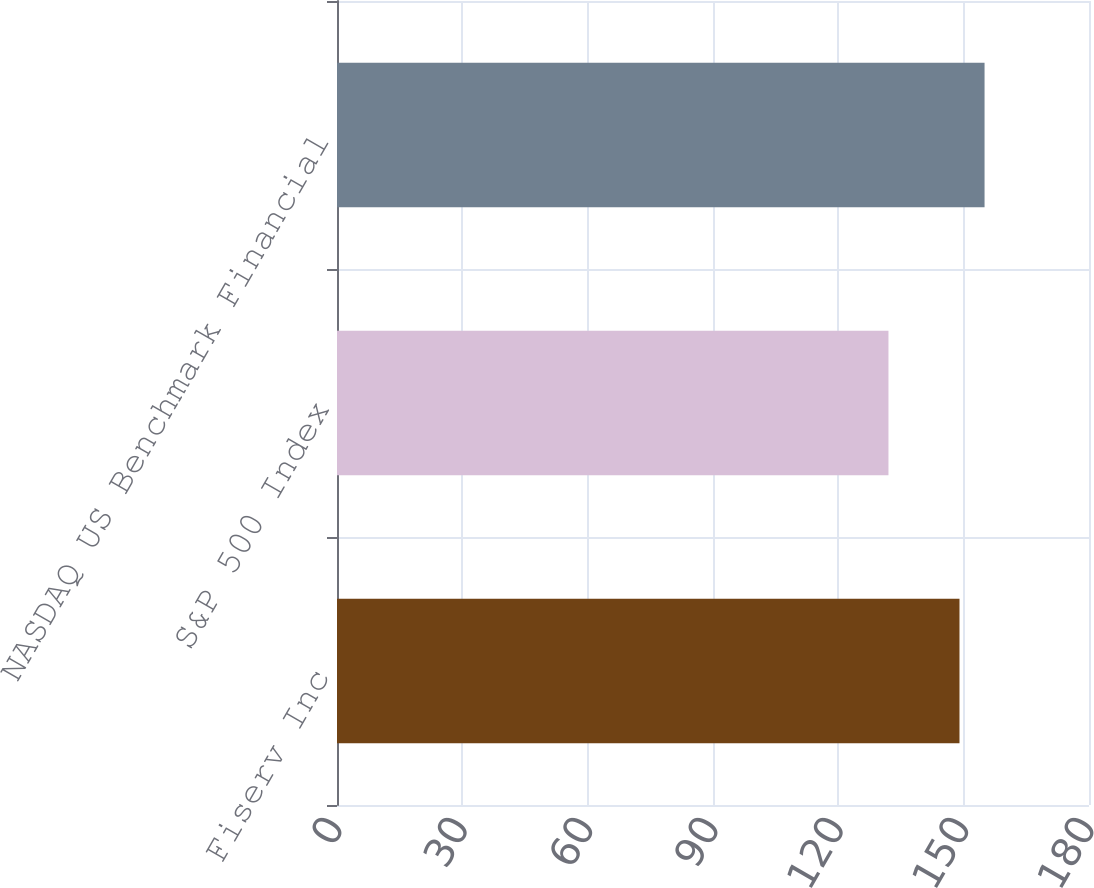Convert chart to OTSL. <chart><loc_0><loc_0><loc_500><loc_500><bar_chart><fcel>Fiserv Inc<fcel>S&P 500 Index<fcel>NASDAQ US Benchmark Financial<nl><fcel>149<fcel>132<fcel>155<nl></chart> 